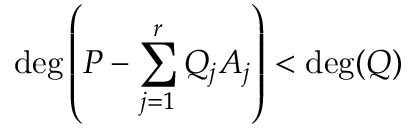Convert formula to latex. <formula><loc_0><loc_0><loc_500><loc_500>\deg \left ( P - \sum _ { j = 1 } ^ { r } Q _ { j } A _ { j } \right ) < \deg ( Q )</formula> 